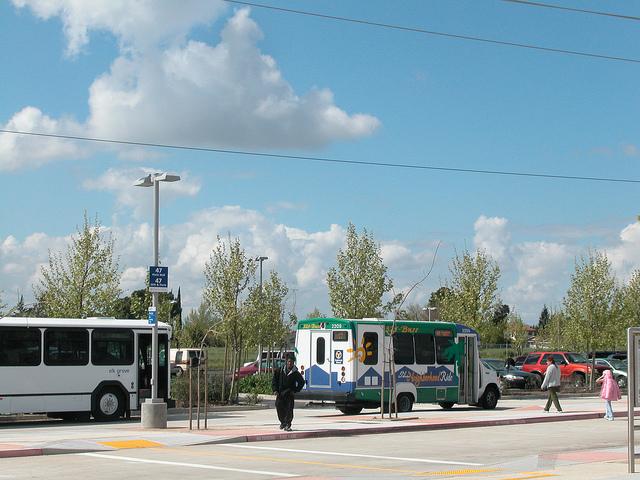Is this a train station?
Be succinct. No. Which direction are the vehicles facing?
Give a very brief answer. Right. Are the buses multi level?
Quick response, please. No. How many power lines?
Concise answer only. 3. How many people can be seen?
Give a very brief answer. 3. Are there any people walking on the street?
Concise answer only. Yes. What is in the sky?
Answer briefly. Clouds. Is the bus moving?
Short answer required. No. Are there a lot of people walking near the road?
Answer briefly. No. What is the sex of the person standing?
Keep it brief. Male. 